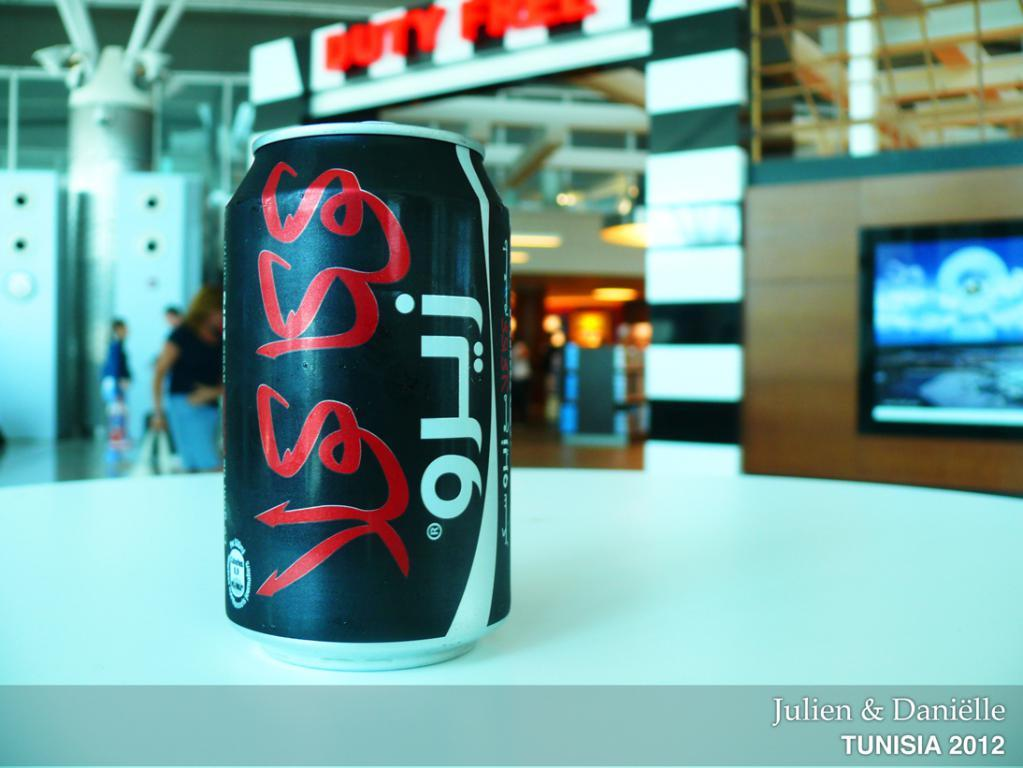<image>
Describe the image concisely. A beverage can with foreign text on  it and the photo says Tunisia 2012 in the corner. 